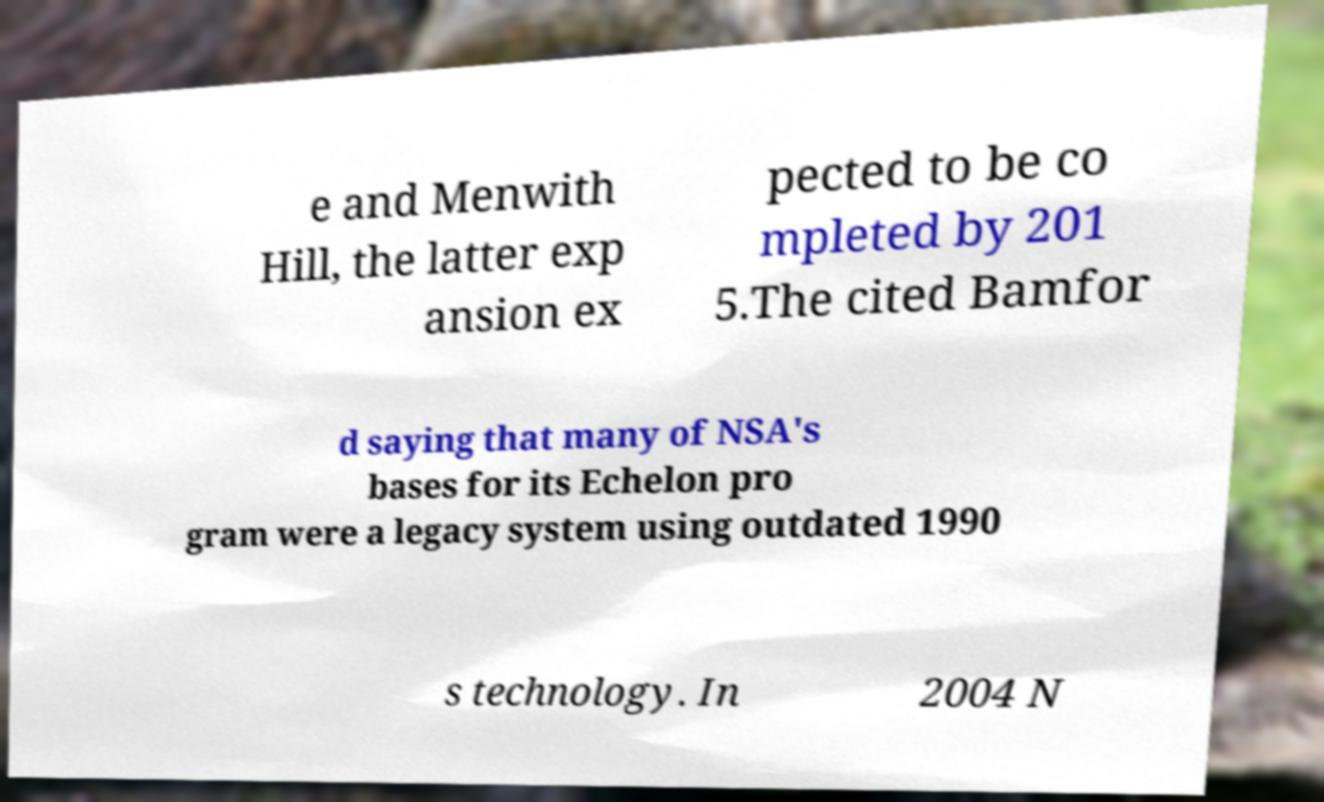What messages or text are displayed in this image? I need them in a readable, typed format. e and Menwith Hill, the latter exp ansion ex pected to be co mpleted by 201 5.The cited Bamfor d saying that many of NSA's bases for its Echelon pro gram were a legacy system using outdated 1990 s technology. In 2004 N 